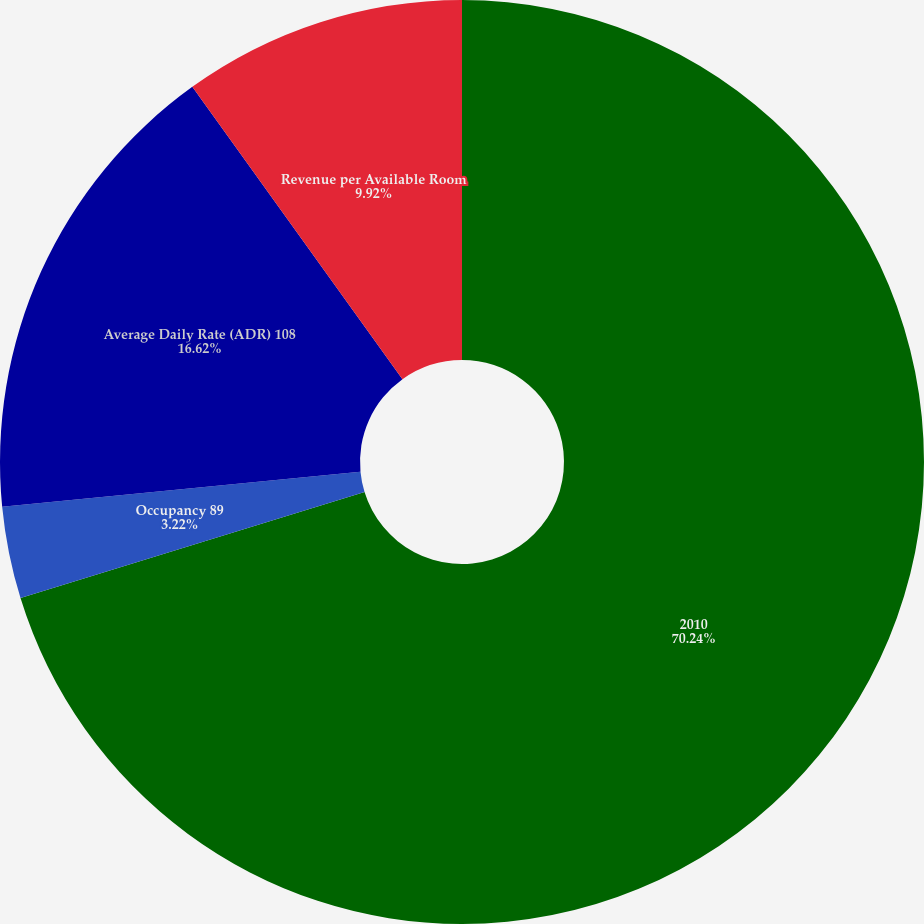Convert chart. <chart><loc_0><loc_0><loc_500><loc_500><pie_chart><fcel>2010<fcel>Occupancy 89<fcel>Average Daily Rate (ADR) 108<fcel>Revenue per Available Room<nl><fcel>70.24%<fcel>3.22%<fcel>16.62%<fcel>9.92%<nl></chart> 